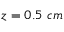<formula> <loc_0><loc_0><loc_500><loc_500>z = 0 . 5 { c m }</formula> 